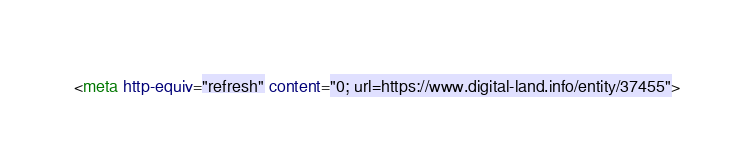<code> <loc_0><loc_0><loc_500><loc_500><_HTML_><meta http-equiv="refresh" content="0; url=https://www.digital-land.info/entity/37455"></code> 